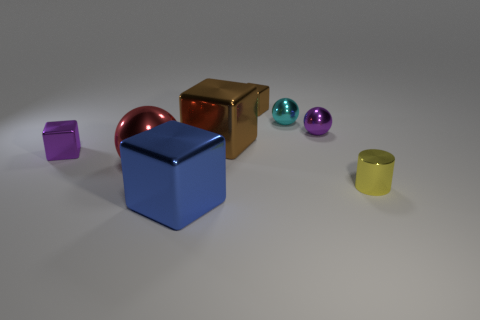Are there fewer tiny purple metallic blocks than purple rubber blocks?
Your response must be concise. No. Does the tiny block on the right side of the large blue metallic object have the same material as the object to the left of the big red object?
Your answer should be compact. Yes. Are there fewer small purple cubes on the right side of the small purple metal ball than big gray rubber objects?
Ensure brevity in your answer.  No. How many objects are in front of the metallic thing that is on the right side of the tiny purple shiny ball?
Offer a very short reply. 1. What size is the metal cube that is in front of the large brown shiny object and to the right of the large red thing?
Keep it short and to the point. Large. Are the cylinder and the big object that is in front of the small yellow thing made of the same material?
Your response must be concise. Yes. Is the number of purple shiny blocks right of the large blue shiny block less than the number of cubes behind the large metallic sphere?
Your response must be concise. Yes. What color is the shiny thing that is to the right of the small cyan ball and left of the small cylinder?
Your answer should be very brief. Purple. There is a metal ball to the left of the cyan sphere; what is its color?
Offer a very short reply. Red. Is there another shiny block that has the same size as the blue cube?
Provide a short and direct response. Yes. 